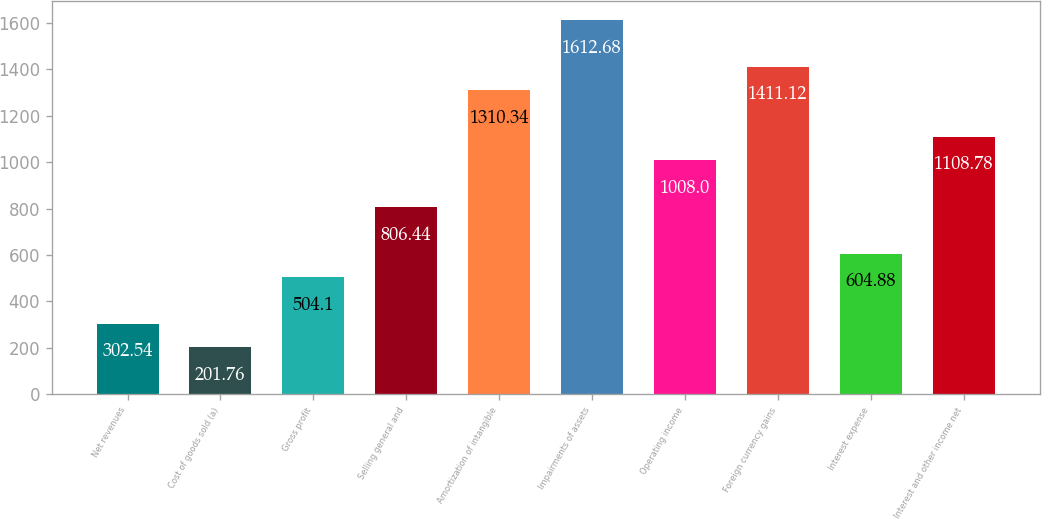Convert chart to OTSL. <chart><loc_0><loc_0><loc_500><loc_500><bar_chart><fcel>Net revenues<fcel>Cost of goods sold (a)<fcel>Gross profit<fcel>Selling general and<fcel>Amortization of intangible<fcel>Impairments of assets<fcel>Operating income<fcel>Foreign currency gains<fcel>Interest expense<fcel>Interest and other income net<nl><fcel>302.54<fcel>201.76<fcel>504.1<fcel>806.44<fcel>1310.34<fcel>1612.68<fcel>1008<fcel>1411.12<fcel>604.88<fcel>1108.78<nl></chart> 